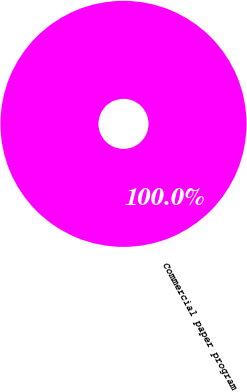Convert chart. <chart><loc_0><loc_0><loc_500><loc_500><pie_chart><fcel>Commercial paper program<nl><fcel>100.0%<nl></chart> 